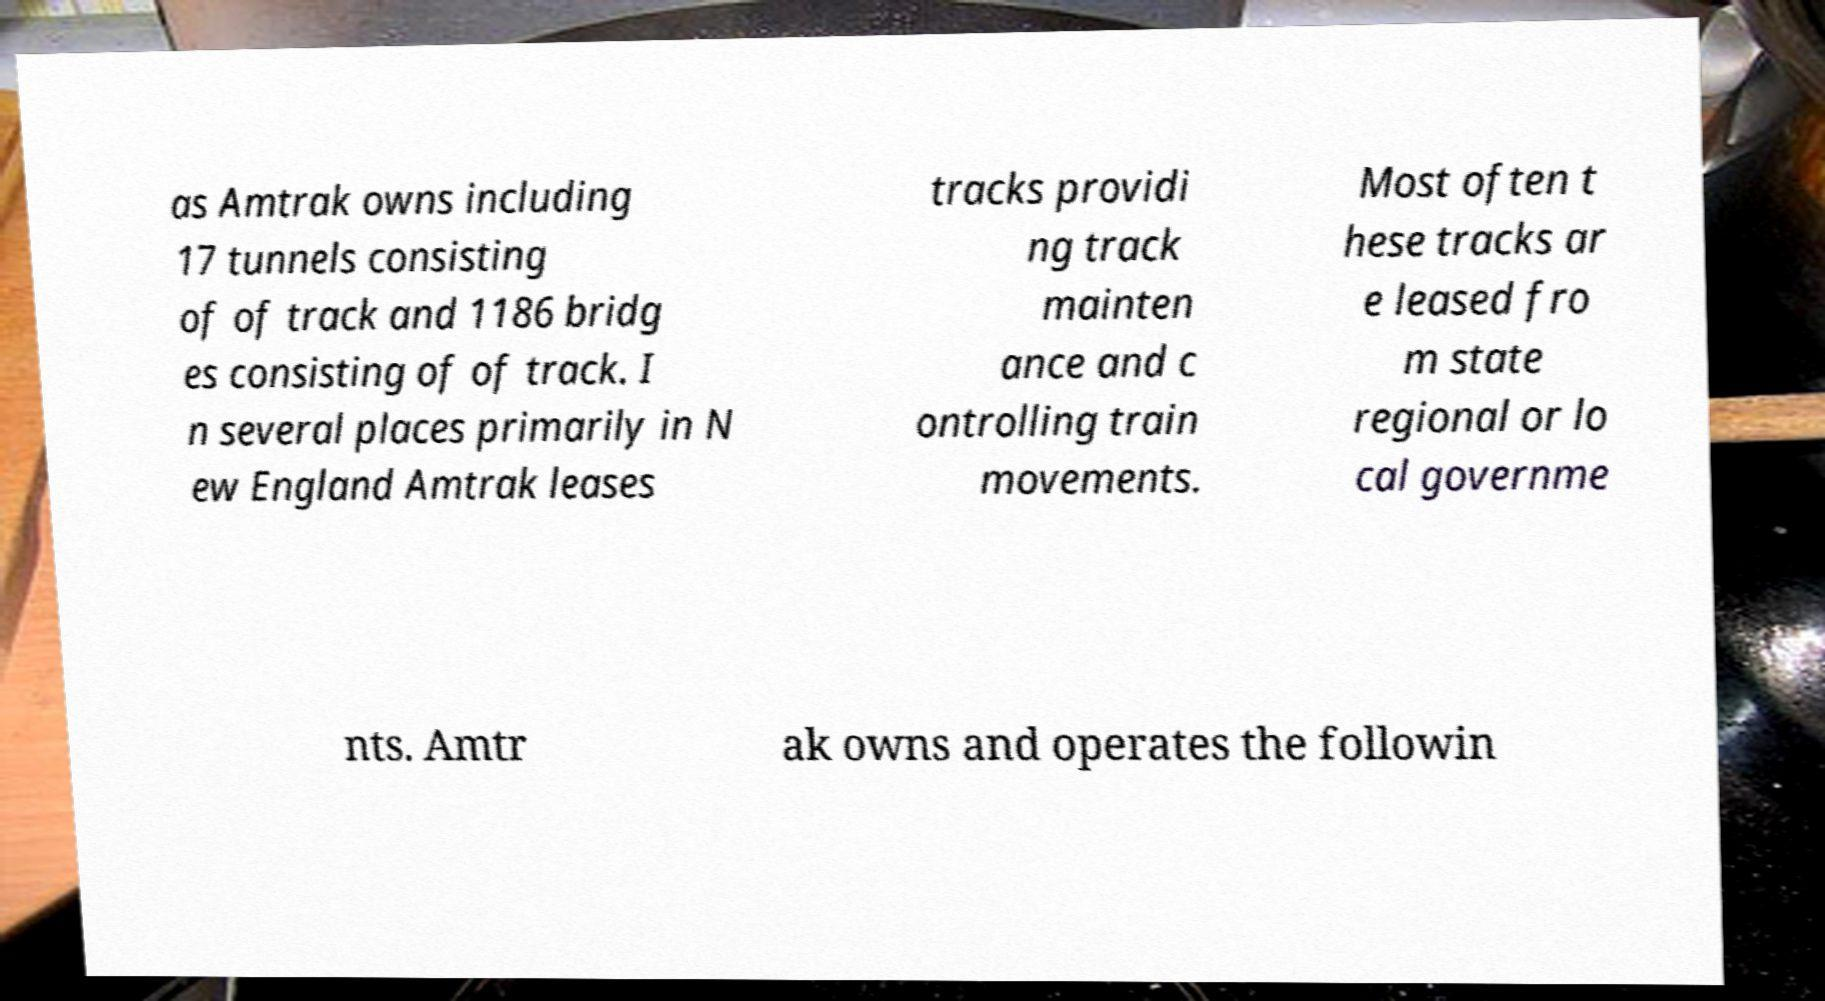There's text embedded in this image that I need extracted. Can you transcribe it verbatim? as Amtrak owns including 17 tunnels consisting of of track and 1186 bridg es consisting of of track. I n several places primarily in N ew England Amtrak leases tracks providi ng track mainten ance and c ontrolling train movements. Most often t hese tracks ar e leased fro m state regional or lo cal governme nts. Amtr ak owns and operates the followin 